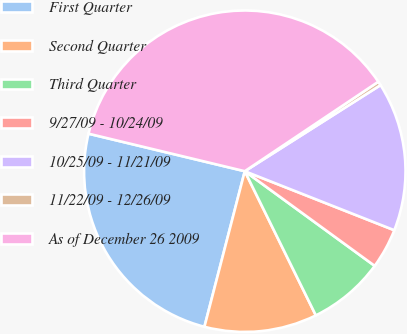Convert chart to OTSL. <chart><loc_0><loc_0><loc_500><loc_500><pie_chart><fcel>First Quarter<fcel>Second Quarter<fcel>Third Quarter<fcel>9/27/09 - 10/24/09<fcel>10/25/09 - 11/21/09<fcel>11/22/09 - 12/26/09<fcel>As of December 26 2009<nl><fcel>24.71%<fcel>11.33%<fcel>7.69%<fcel>4.04%<fcel>14.98%<fcel>0.4%<fcel>36.85%<nl></chart> 